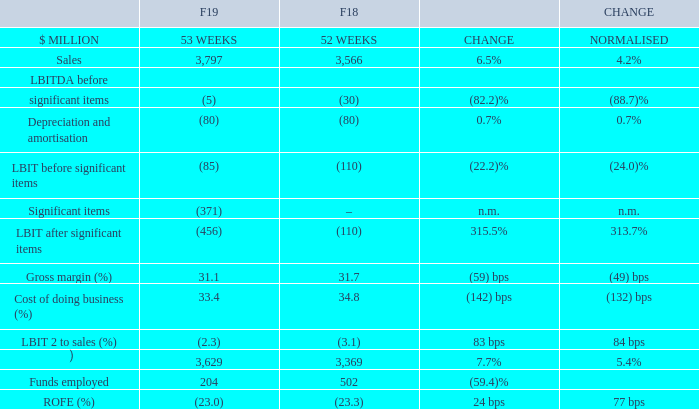BIG W’s Store‐controllable VOC and VOC NPS improved on the prior year with higher customer scores translating into sales, with an increase in F19 of 4.2% on a normalised basis to $3.8 billion. Comparable sales increased by 5.3% in F19 and 7.2% in Q4 (Easter‐adjusted) with growth in all customer universes.
BIG W’s growth continues to be driven by an increase in customer transactions (F19: 4.0%) and customers increasingly putting more items in their baskets with comparable items per basket growth of 4.4%. Together this drove comparable item growth of 8.6%. Excluding reusable bags, comparable items increased by 5.2%.
With BIG W’s turnaround gaining momentum, and to build a sustainable network for the future, a store and DC network review was announced in April. BIG W intends to close approximately 30 stores over the next three years and two distribution centres at the end of their leases. The review of the store network is ongoing, with three stores recently announced to be closed in F20.
BIG W has remained price competitive, improved ranges and built a convenient online and in‐store experience in F19.
Normalised Online sales increased by 128% in F19 with Pick up consistently delivering strong sales growth. Apparel, which has been more challenging, improved steadily through H2 due to a focus on range, stock flow and in‐store execution.
Normalised gross profit declined 49 bps for F19 reflecting continued challenges in stockloss as well as slow sell‐through of seasonal apparel in H1. Category mix improved in H2 with improved apparel sell‐through.
Normalised CODB declined 132 bps resulting from store efficiencies and sales growth fractionalising fixed costs.
The LBIT of $85 million before significant items excludes a $371 million charge identified as part of the network review.
Funds employed declined primarily due to significant items provisions. Inventory quality has improved as a result of solid sales and improved apparel sell‐through in H2.
In F20, BIG W will focus on creating a sustainable business that is simpler to operate, and continue providing customers with low prices and more convenient, connected solutions in‐store and online.
What is the focus of BIG W in F20? In f20, big w will focus on creating a sustainable business that is simpler to operate, and continue providing customers with low prices and more convenient, connected solutions in‐store and online. What is the gross margin in F19?
Answer scale should be: percent. 31.1. Why did the funds employed declined? Funds employed declined primarily due to significant items provisions. What is the nominal difference between the sales in F19 and F18?
Answer scale should be: million. 3,797 - 3,566 
Answer: 231. What is the average cost of doing business (%) for both F19 and F18?
Answer scale should be: percent. (33.4 + 34.8)/2 
Answer: 34.1. What is the nominal difference between sales per square metre for F19 and F18?
Answer scale should be: million. 3,629 - 3,369 
Answer: 260. 